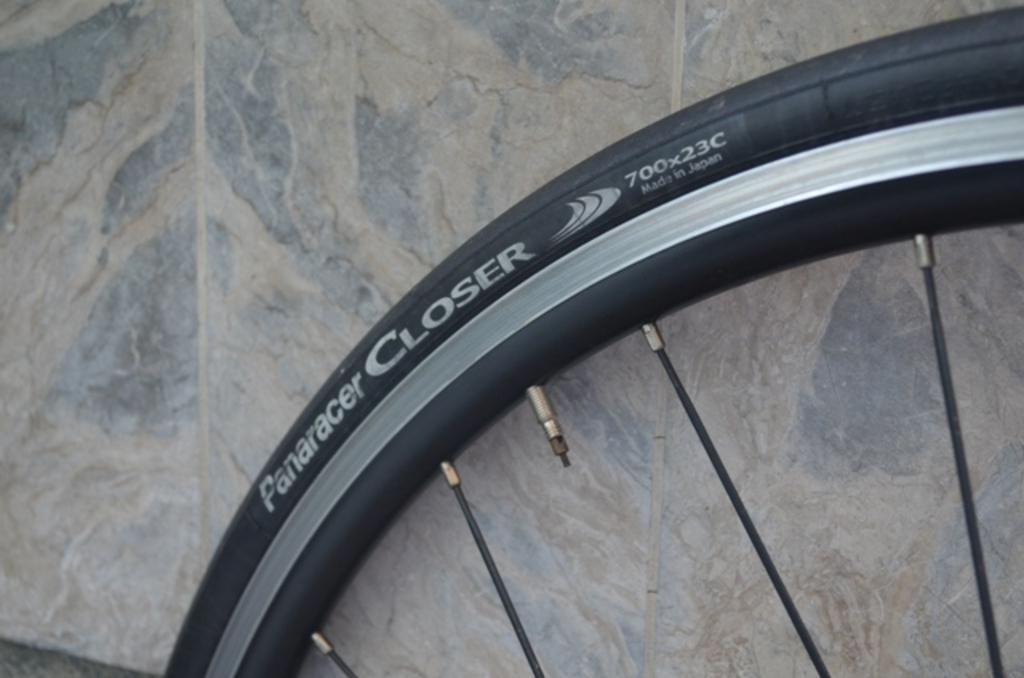What object is present in the image that has a circular shape? There is a wheel in the image. What can be found on the surface of the wheel? There is text on the wheel. Can you touch the neck of the person in the image? There is no person present in the image, so it is not possible to touch their neck. 